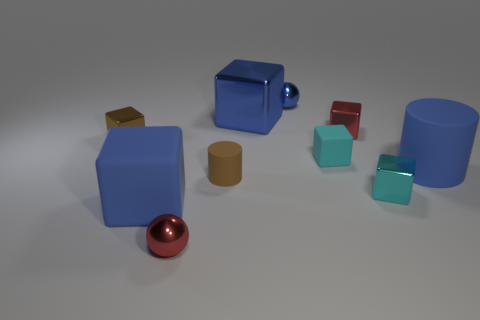The big rubber thing that is the same shape as the brown metallic object is what color?
Provide a short and direct response. Blue. There is a matte thing that is on the left side of the red sphere; does it have the same color as the ball that is behind the tiny brown cube?
Provide a succinct answer. Yes. Is the number of spheres that are right of the tiny red metal sphere greater than the number of yellow objects?
Your response must be concise. Yes. What number of other things are there of the same size as the brown matte cylinder?
Offer a very short reply. 6. How many small things are behind the tiny red sphere and to the left of the blue metallic cube?
Keep it short and to the point. 2. Are the sphere in front of the small brown cylinder and the blue sphere made of the same material?
Ensure brevity in your answer.  Yes. What is the shape of the big blue rubber object right of the small sphere behind the big blue thing behind the blue cylinder?
Your answer should be compact. Cylinder. Is the number of cyan objects that are behind the brown block the same as the number of blue cubes on the right side of the brown cylinder?
Your answer should be compact. No. What is the color of the metallic object that is the same size as the blue cylinder?
Ensure brevity in your answer.  Blue. What number of large things are brown shiny cubes or cyan metal things?
Provide a succinct answer. 0. 